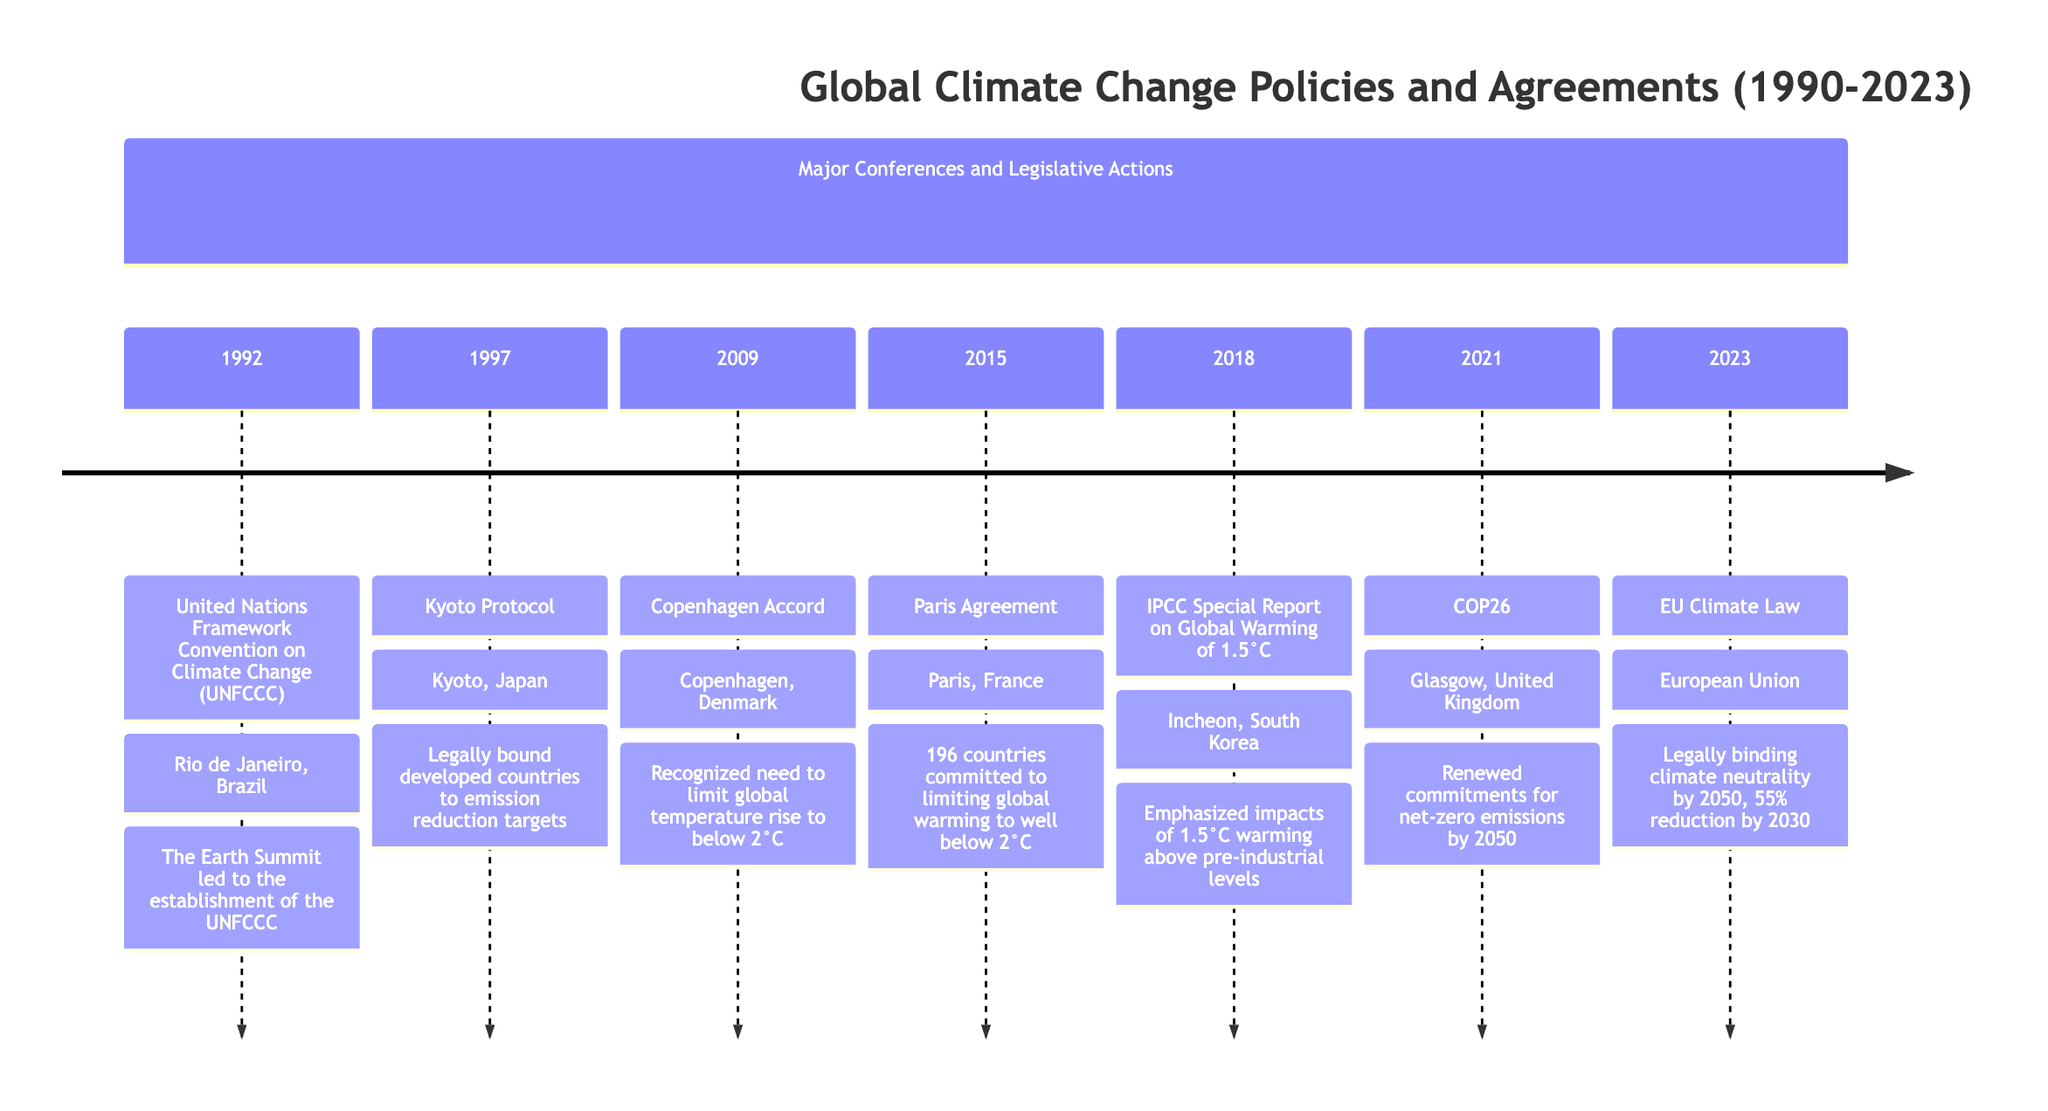What year was the Kyoto Protocol adopted? In the timeline, the Kyoto Protocol is noted under the year 1997, which directly indicates the year of its adoption.
Answer: 1997 What event was established in 1992 at the Earth Summit? The Earth Summit led to the establishment of the United Nations Framework Convention on Climate Change (UNFCCC), which is the designated event for that year.
Answer: United Nations Framework Convention on Climate Change (UNFCCC) How many countries committed to the Paris Agreement? The Paris Agreement mentions that 196 countries committed to limiting global warming, which is clearly stated in the event description for 2015.
Answer: 196 Which event emphasizes the impacts of global warming of 1.5°C? The timeline notes that the IPCC Special Report on Global Warming of 1.5°C highlights these impacts, making it the event that focuses on this specific temperature rise.
Answer: IPCC Special Report on Global Warming of 1.5°C What is the interim target set by the EU Climate Law for 2030? According to the description of the EU Climate Law in 2023, the interim target is explicitly stated as a 55% reduction in emissions by 2030.
Answer: 55% reduction What major climate goal was discussed at COP26? The description for COP26 in 2021 mentions that countries made renewed commitments to achieving net-zero emissions by 2050, highlighting a significant climate goal addressed at this event.
Answer: Net-zero emissions by 2050 Which city hosted the Copenhagen Accord? The timeline indicates that the Copenhagen Accord was reached in Copenhagen, Denmark during the event in 2009, directly identifying the hosting city.
Answer: Copenhagen What major theme emerged from the discussions at the 2018 conference? The 2018 event focused on the impacts of global warming of 1.5°C above pre-industrial levels, making this the prominent theme of the IPCC report released that year.
Answer: Impacts of global warming of 1.5°C In what year did the EU Climate Law enter into force? The timeline clearly states that the EU Climate Law legislation entered into force in 2023, allowing for a straightforward identification of the year.
Answer: 2023 